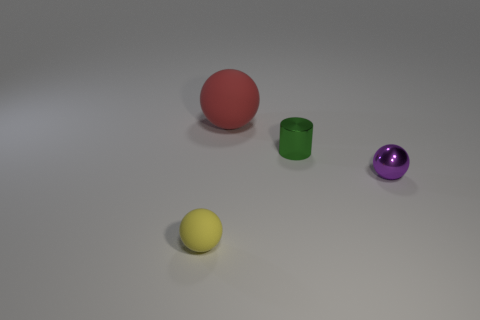Is the shiny cylinder the same size as the red sphere?
Your answer should be compact. No. The sphere that is behind the small thing that is behind the small purple metallic ball is made of what material?
Your answer should be very brief. Rubber. Is the tiny purple thing the same shape as the red matte object?
Make the answer very short. Yes. How big is the matte ball that is behind the small rubber object?
Offer a terse response. Large. There is a shiny cylinder that is behind the tiny yellow ball; does it have the same size as the rubber thing left of the red ball?
Offer a terse response. Yes. What is the color of the metallic ball?
Your answer should be compact. Purple. Does the object that is behind the tiny green object have the same shape as the small purple object?
Provide a short and direct response. Yes. What material is the tiny yellow sphere?
Your answer should be compact. Rubber. The metal object that is the same size as the purple metal ball is what shape?
Give a very brief answer. Cylinder. Is there a large ball that has the same color as the tiny matte thing?
Provide a succinct answer. No. 